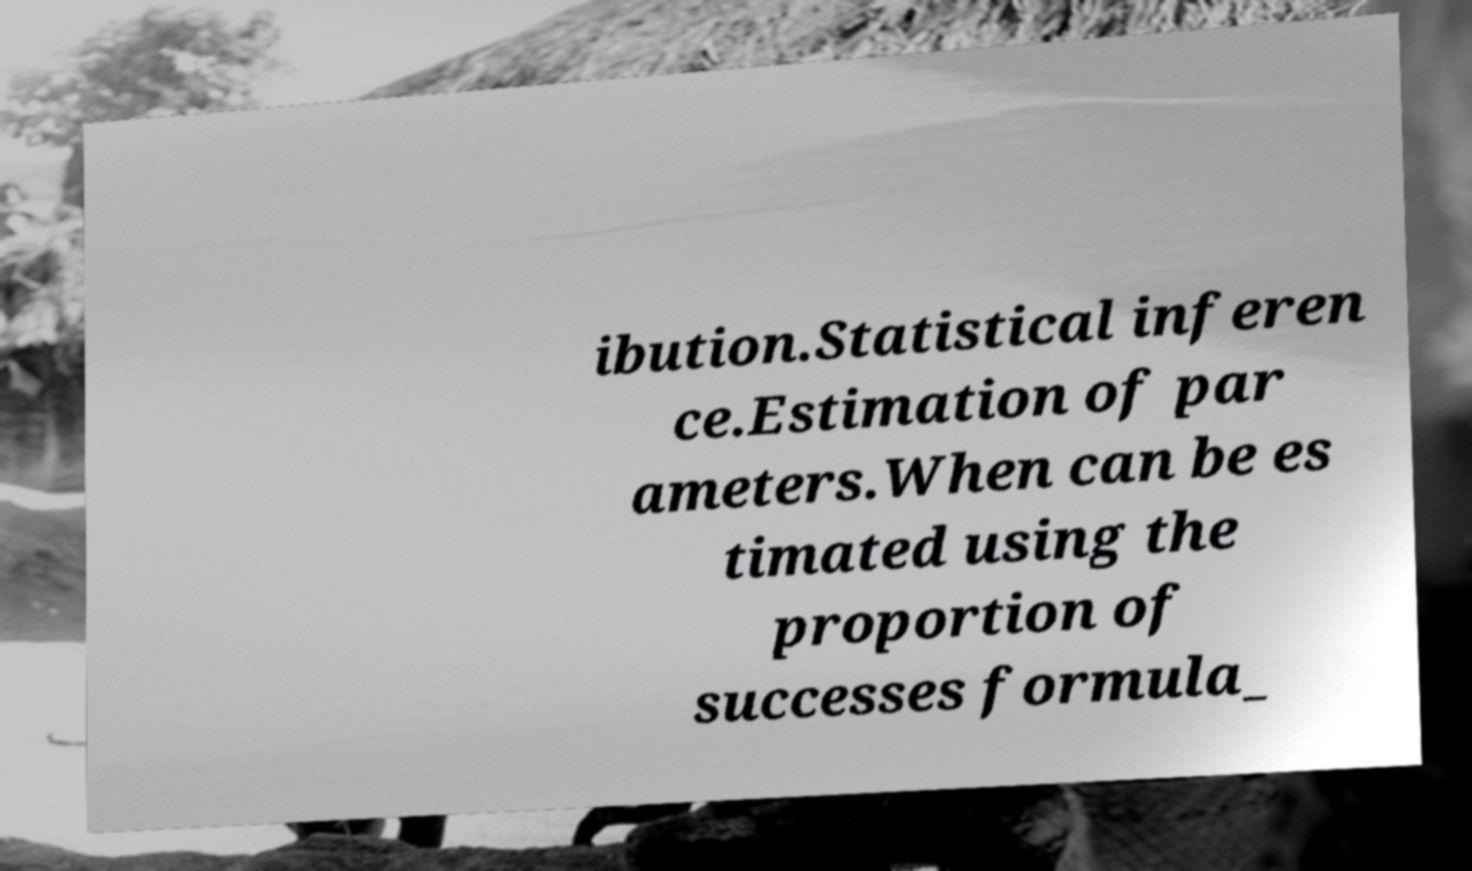Can you accurately transcribe the text from the provided image for me? ibution.Statistical inferen ce.Estimation of par ameters.When can be es timated using the proportion of successes formula_ 